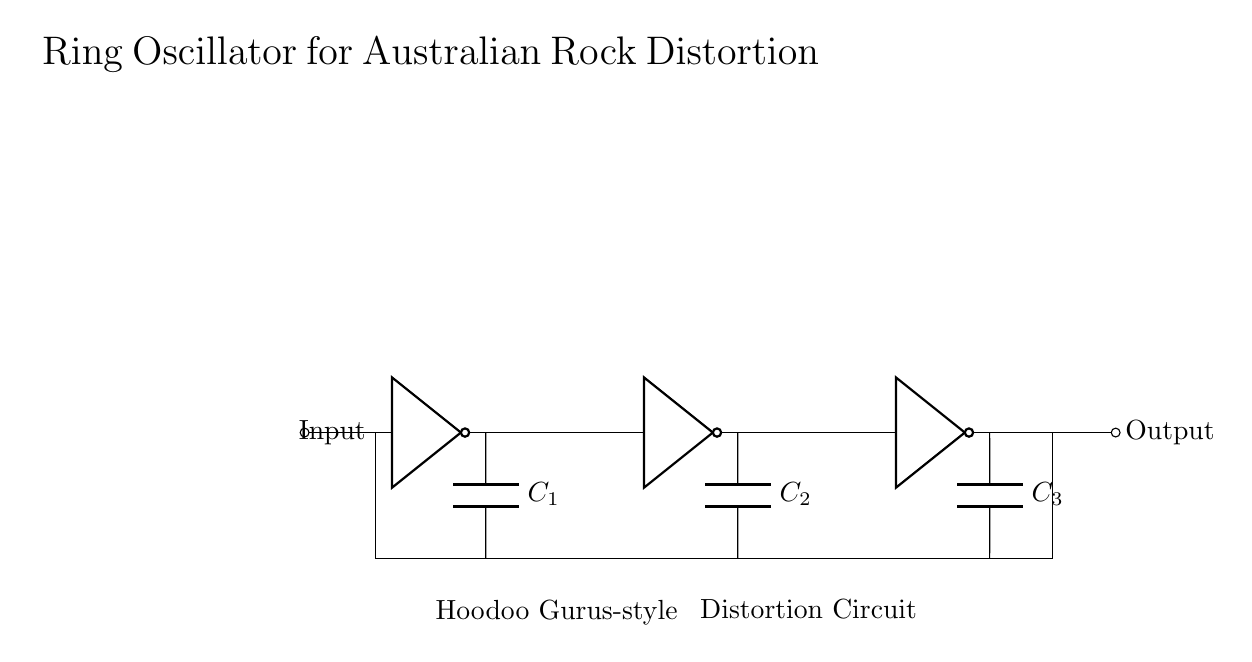What type of circuit is this? This is a ring oscillator circuit, which consists of multiple inverters connected in a loop to create oscillations.
Answer: Ring oscillator How many inverters are present in the circuit? There are three inverters in the circuit, as indicated by the three not gate symbols.
Answer: Three What is the function of the capacitors in this circuit? The capacitors are used to shape the waveform and introduce a phase shift in the oscillation, affecting the distortion effects for guitar amplification.
Answer: Phase shift Which band is associated with the style indicated in the circuit? The circuit is styled to reflect the characteristics of Hoodoo Gurus, a significant band in the Australian rock scene.
Answer: Hoodoo Gurus How are the inverters connected in relation to each other? The inverters are connected in a series loop where the output of one feeds into the input of the next, completing the feedback loop needed for oscillation.
Answer: Series loop What does the output represent in the context of this circuit? The output represents the distorted audio signal resulting from the oscillations, which can be used in electric guitar amplifiers to create unique sound effects.
Answer: Distorted audio signal What is indicated below the first and second inverters in the circuit? Below the first inverter, it indicates "Hoodoo Gurus-style," and below the second inverter, it indicates "Distortion Circuit," highlighting the intended application of the design.
Answer: Hoodoo Gurus-style; Distortion Circuit 